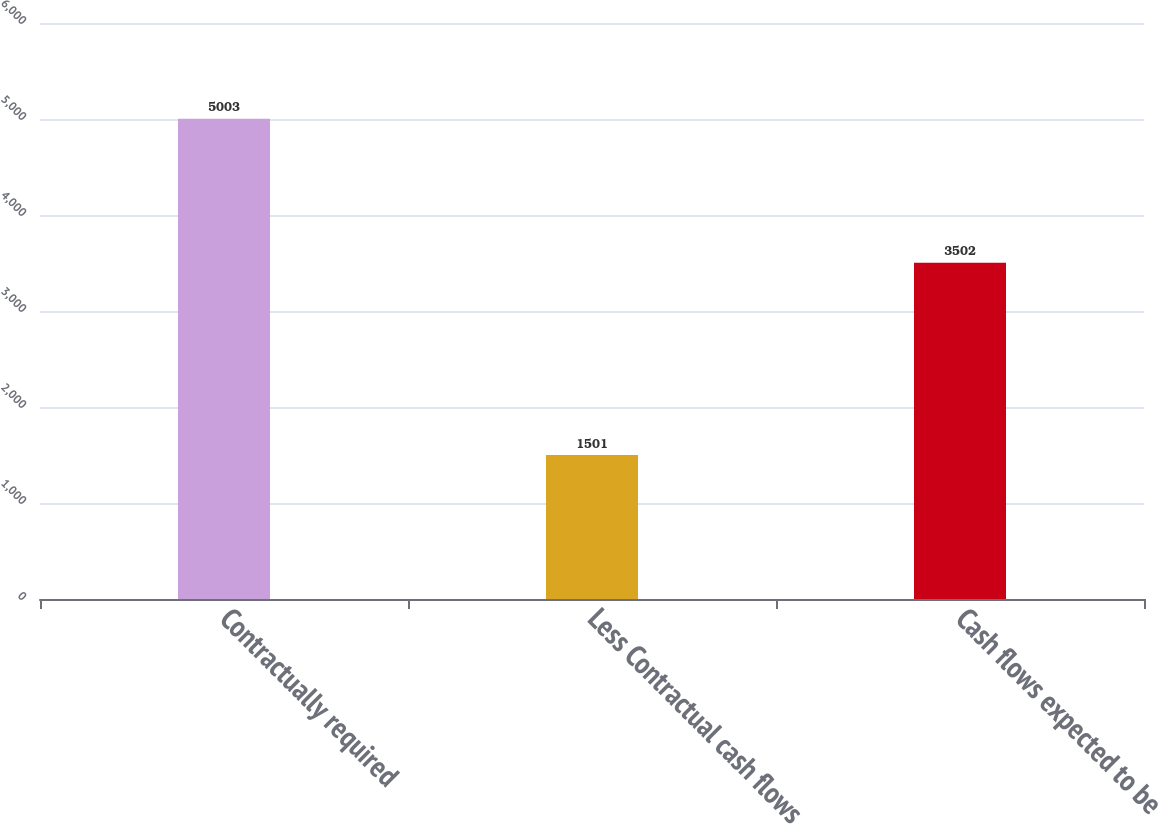<chart> <loc_0><loc_0><loc_500><loc_500><bar_chart><fcel>Contractually required<fcel>Less Contractual cash flows<fcel>Cash flows expected to be<nl><fcel>5003<fcel>1501<fcel>3502<nl></chart> 